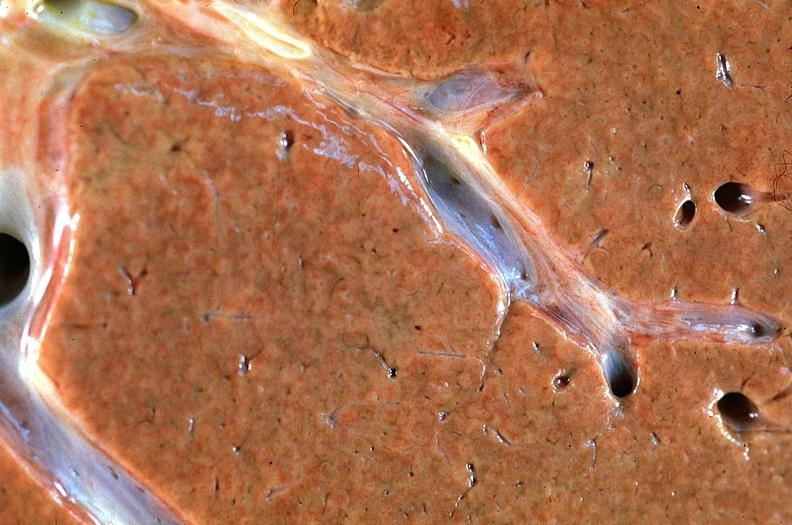does this image show normal liver?
Answer the question using a single word or phrase. Yes 